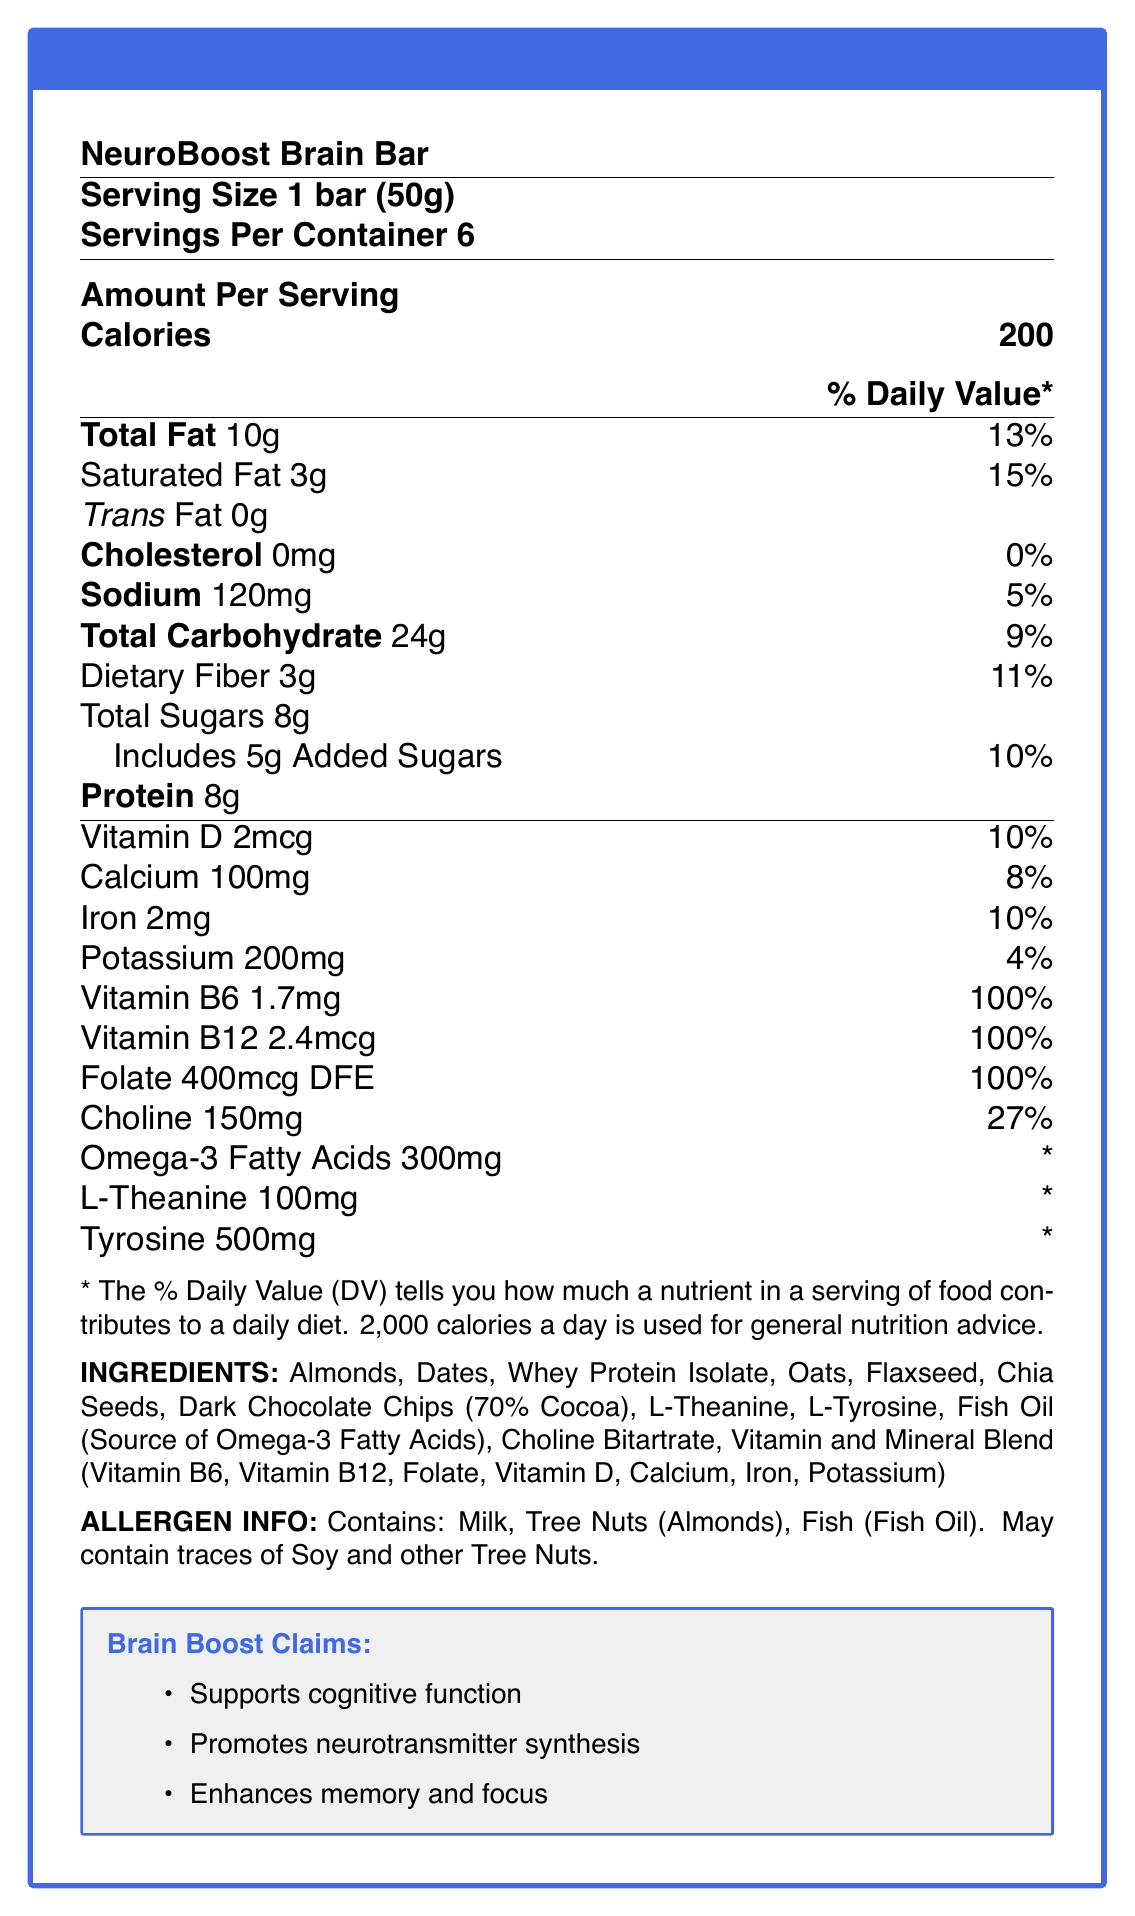what is the serving size? The serving size is explicitly listed as "1 bar (50g)" in the document.
Answer: 1 bar (50g) how many calories are in one serving of NeuroBoost Brain Bar? The calories per serving are listed as 200.
Answer: 200 which nutrient has the highest % Daily Value per serving? The document indicates that Vitamin B6, Vitamin B12, and Folate each have a 100% Daily Value per serving, which is the highest among the listed nutrients.
Answer: Vitamin B6, Vitamin B12, and Folate (100%) how much protein does one bar contain? The protein content per serving is listed as 8g.
Answer: 8g what are the main ingredients of the NeuroBoost Brain Bar? The ingredients are listed under the "INGREDIENTS" section.
Answer: Almonds, Dates, Whey Protein Isolate, Oats, Flaxseed, Chia Seeds, Dark Chocolate Chips (70% Cocoa), L-Theanine, L-Tyrosine, Fish Oil (Source of Omega-3 Fatty Acids), Choline Bitartrate, Vitamin and Mineral Blend (Vitamin B6, Vitamin B12, Folate, Vitamin D, Calcium, Iron, Potassium) which vitamins and minerals are claimed to support cognitive function? The ingredients that help cognitive function include Vitamin B6, Vitamin B12, Folate, and Choline, as indicated by the supporting claims for promoting neurotransmitter synthesis.
Answer: Vitamin B6, Vitamin B12, Folate, Choline how much sodium is there in one serving? The sodium content per serving is listed as 120mg.
Answer: 120mg which allergen information is provided for the NeuroBoost Brain Bar? The allergen information section lists these allergens.
Answer: Contains: Milk, Tree Nuts (Almonds), Fish (Fish Oil). May contain traces of Soy and other Tree Nuts. how much L-Theanine does one bar contain? The amount is specified as 100mg in the document under L-Theanine.
Answer: 100mg Does the NeuroBoost Brain Bar contain any trans fat? The document indicates that the trans fat content is 0g.
Answer: No which nutrient listed does not have an established daily value? A. Vitamin B6 B. Omega-3 Fatty Acids C. Calcium The document marks Omega-3 Fatty Acids with an asterisk indicating that the daily value is not established for this nutrient.
Answer: B how many grams of added sugars are in one serving? A. 10g B. 5g C. 8g D. 3g The added sugars per serving are listed as 5g.
Answer: B does the product contain any cholesterol? The document lists 0mg cholesterol per serving, which equals 0% Daily Value.
Answer: No is there any way to determine whether the product is gluten-free based on the document? The document does not provide any information regarding gluten content or gluten-free claims.
Answer: Not enough information summarize the document. The document is a comprehensive nutrition facts label highlighting the nutritional content, ingredients, allergy information, and cognitive health benefits of the NeuroBoost Brain Bar.
Answer: The document provides detailed nutrition facts for the NeuroBoost Brain Bar, a snack marketed as "brain food" that contains various ingredients and nutrients supporting cognitive function. These include neurotransmitter precursors and micronutrients such as Vitamin B6, B12, Folate, Choline, Omega-3 Fatty Acids, L-Theanine, and Tyrosine. The Nutrition Facts label outlines serving size, calories, and daily value percentages for each nutrient. Additionally, it lists all ingredients and notes allergen information. The product claims to support cognitive function, promote neurotransmitter synthesis, and enhance memory and focus. 